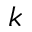Convert formula to latex. <formula><loc_0><loc_0><loc_500><loc_500>k</formula> 